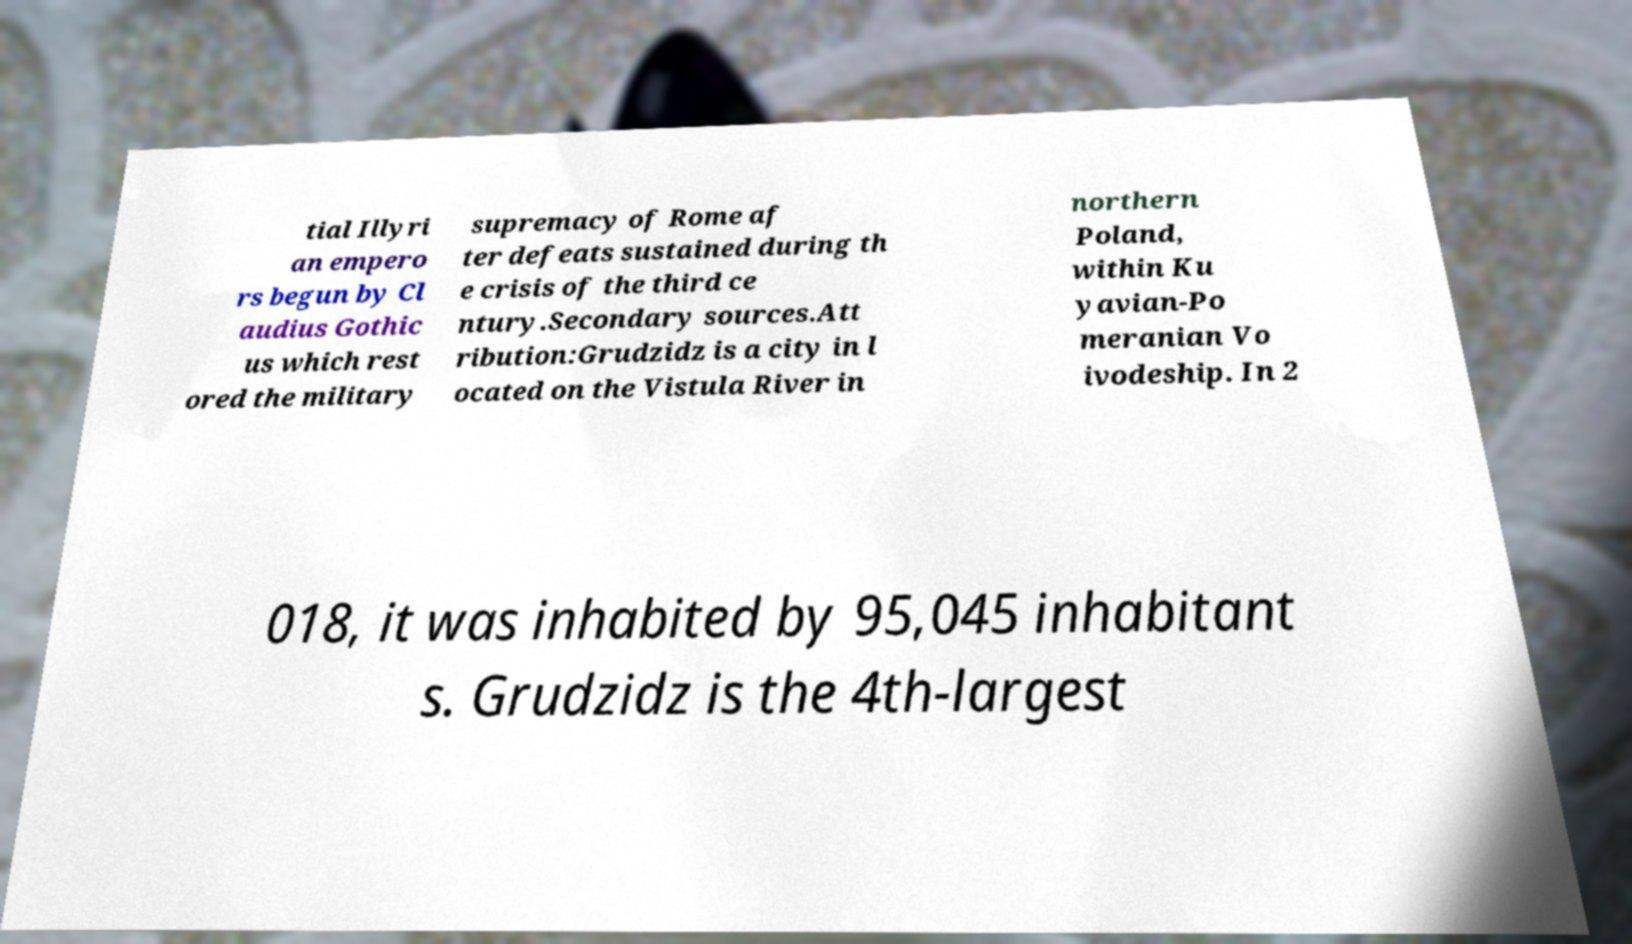Could you extract and type out the text from this image? tial Illyri an empero rs begun by Cl audius Gothic us which rest ored the military supremacy of Rome af ter defeats sustained during th e crisis of the third ce ntury.Secondary sources.Att ribution:Grudzidz is a city in l ocated on the Vistula River in northern Poland, within Ku yavian-Po meranian Vo ivodeship. In 2 018, it was inhabited by 95,045 inhabitant s. Grudzidz is the 4th-largest 